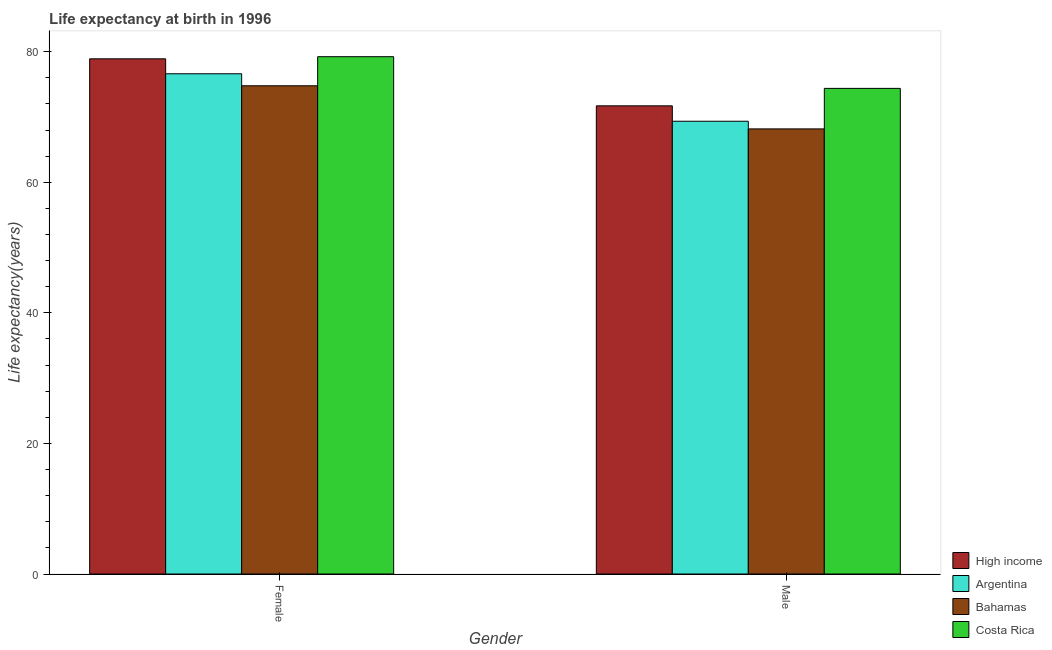How many groups of bars are there?
Your response must be concise. 2. Are the number of bars per tick equal to the number of legend labels?
Your answer should be very brief. Yes. How many bars are there on the 1st tick from the left?
Offer a terse response. 4. What is the label of the 2nd group of bars from the left?
Ensure brevity in your answer.  Male. What is the life expectancy(male) in High income?
Your response must be concise. 71.7. Across all countries, what is the maximum life expectancy(female)?
Ensure brevity in your answer.  79.23. Across all countries, what is the minimum life expectancy(male)?
Ensure brevity in your answer.  68.17. In which country was the life expectancy(male) maximum?
Offer a very short reply. Costa Rica. In which country was the life expectancy(female) minimum?
Keep it short and to the point. Bahamas. What is the total life expectancy(male) in the graph?
Offer a very short reply. 283.58. What is the difference between the life expectancy(male) in High income and that in Bahamas?
Provide a short and direct response. 3.53. What is the difference between the life expectancy(male) in Bahamas and the life expectancy(female) in High income?
Give a very brief answer. -10.73. What is the average life expectancy(female) per country?
Your answer should be compact. 77.38. What is the difference between the life expectancy(female) and life expectancy(male) in High income?
Ensure brevity in your answer.  7.2. What is the ratio of the life expectancy(male) in High income to that in Argentina?
Keep it short and to the point. 1.03. Is the life expectancy(male) in High income less than that in Argentina?
Your answer should be compact. No. What does the 1st bar from the left in Female represents?
Provide a short and direct response. High income. How many bars are there?
Make the answer very short. 8. Are all the bars in the graph horizontal?
Your response must be concise. No. How many countries are there in the graph?
Provide a short and direct response. 4. What is the difference between two consecutive major ticks on the Y-axis?
Make the answer very short. 20. Does the graph contain grids?
Your response must be concise. No. Where does the legend appear in the graph?
Provide a short and direct response. Bottom right. How are the legend labels stacked?
Keep it short and to the point. Vertical. What is the title of the graph?
Keep it short and to the point. Life expectancy at birth in 1996. Does "Comoros" appear as one of the legend labels in the graph?
Offer a very short reply. No. What is the label or title of the X-axis?
Give a very brief answer. Gender. What is the label or title of the Y-axis?
Your response must be concise. Life expectancy(years). What is the Life expectancy(years) of High income in Female?
Provide a succinct answer. 78.9. What is the Life expectancy(years) of Argentina in Female?
Offer a terse response. 76.61. What is the Life expectancy(years) in Bahamas in Female?
Ensure brevity in your answer.  74.77. What is the Life expectancy(years) in Costa Rica in Female?
Your answer should be very brief. 79.23. What is the Life expectancy(years) in High income in Male?
Your answer should be compact. 71.7. What is the Life expectancy(years) in Argentina in Male?
Your answer should be very brief. 69.34. What is the Life expectancy(years) of Bahamas in Male?
Offer a very short reply. 68.17. What is the Life expectancy(years) in Costa Rica in Male?
Provide a short and direct response. 74.37. Across all Gender, what is the maximum Life expectancy(years) in High income?
Make the answer very short. 78.9. Across all Gender, what is the maximum Life expectancy(years) of Argentina?
Offer a terse response. 76.61. Across all Gender, what is the maximum Life expectancy(years) of Bahamas?
Your response must be concise. 74.77. Across all Gender, what is the maximum Life expectancy(years) in Costa Rica?
Your answer should be compact. 79.23. Across all Gender, what is the minimum Life expectancy(years) in High income?
Your response must be concise. 71.7. Across all Gender, what is the minimum Life expectancy(years) of Argentina?
Keep it short and to the point. 69.34. Across all Gender, what is the minimum Life expectancy(years) in Bahamas?
Provide a short and direct response. 68.17. Across all Gender, what is the minimum Life expectancy(years) in Costa Rica?
Your answer should be very brief. 74.37. What is the total Life expectancy(years) in High income in the graph?
Ensure brevity in your answer.  150.6. What is the total Life expectancy(years) of Argentina in the graph?
Ensure brevity in your answer.  145.95. What is the total Life expectancy(years) in Bahamas in the graph?
Offer a terse response. 142.94. What is the total Life expectancy(years) in Costa Rica in the graph?
Give a very brief answer. 153.6. What is the difference between the Life expectancy(years) of High income in Female and that in Male?
Your answer should be very brief. 7.2. What is the difference between the Life expectancy(years) in Argentina in Female and that in Male?
Ensure brevity in your answer.  7.27. What is the difference between the Life expectancy(years) of Bahamas in Female and that in Male?
Your response must be concise. 6.61. What is the difference between the Life expectancy(years) in Costa Rica in Female and that in Male?
Make the answer very short. 4.85. What is the difference between the Life expectancy(years) of High income in Female and the Life expectancy(years) of Argentina in Male?
Make the answer very short. 9.56. What is the difference between the Life expectancy(years) in High income in Female and the Life expectancy(years) in Bahamas in Male?
Offer a very short reply. 10.73. What is the difference between the Life expectancy(years) in High income in Female and the Life expectancy(years) in Costa Rica in Male?
Give a very brief answer. 4.53. What is the difference between the Life expectancy(years) in Argentina in Female and the Life expectancy(years) in Bahamas in Male?
Your answer should be very brief. 8.44. What is the difference between the Life expectancy(years) in Argentina in Female and the Life expectancy(years) in Costa Rica in Male?
Provide a succinct answer. 2.24. What is the difference between the Life expectancy(years) in Bahamas in Female and the Life expectancy(years) in Costa Rica in Male?
Ensure brevity in your answer.  0.4. What is the average Life expectancy(years) of High income per Gender?
Offer a very short reply. 75.3. What is the average Life expectancy(years) in Argentina per Gender?
Provide a short and direct response. 72.98. What is the average Life expectancy(years) in Bahamas per Gender?
Provide a succinct answer. 71.47. What is the average Life expectancy(years) in Costa Rica per Gender?
Your answer should be compact. 76.8. What is the difference between the Life expectancy(years) in High income and Life expectancy(years) in Argentina in Female?
Your answer should be compact. 2.29. What is the difference between the Life expectancy(years) of High income and Life expectancy(years) of Bahamas in Female?
Provide a short and direct response. 4.13. What is the difference between the Life expectancy(years) in High income and Life expectancy(years) in Costa Rica in Female?
Your response must be concise. -0.33. What is the difference between the Life expectancy(years) in Argentina and Life expectancy(years) in Bahamas in Female?
Give a very brief answer. 1.84. What is the difference between the Life expectancy(years) in Argentina and Life expectancy(years) in Costa Rica in Female?
Your answer should be compact. -2.62. What is the difference between the Life expectancy(years) of Bahamas and Life expectancy(years) of Costa Rica in Female?
Keep it short and to the point. -4.45. What is the difference between the Life expectancy(years) in High income and Life expectancy(years) in Argentina in Male?
Make the answer very short. 2.36. What is the difference between the Life expectancy(years) in High income and Life expectancy(years) in Bahamas in Male?
Provide a succinct answer. 3.53. What is the difference between the Life expectancy(years) of High income and Life expectancy(years) of Costa Rica in Male?
Make the answer very short. -2.67. What is the difference between the Life expectancy(years) of Argentina and Life expectancy(years) of Bahamas in Male?
Ensure brevity in your answer.  1.17. What is the difference between the Life expectancy(years) in Argentina and Life expectancy(years) in Costa Rica in Male?
Your answer should be very brief. -5.03. What is the difference between the Life expectancy(years) of Bahamas and Life expectancy(years) of Costa Rica in Male?
Ensure brevity in your answer.  -6.21. What is the ratio of the Life expectancy(years) of High income in Female to that in Male?
Your answer should be very brief. 1.1. What is the ratio of the Life expectancy(years) of Argentina in Female to that in Male?
Your answer should be very brief. 1.1. What is the ratio of the Life expectancy(years) in Bahamas in Female to that in Male?
Your response must be concise. 1.1. What is the ratio of the Life expectancy(years) of Costa Rica in Female to that in Male?
Give a very brief answer. 1.07. What is the difference between the highest and the second highest Life expectancy(years) of High income?
Provide a succinct answer. 7.2. What is the difference between the highest and the second highest Life expectancy(years) of Argentina?
Ensure brevity in your answer.  7.27. What is the difference between the highest and the second highest Life expectancy(years) of Bahamas?
Ensure brevity in your answer.  6.61. What is the difference between the highest and the second highest Life expectancy(years) in Costa Rica?
Offer a very short reply. 4.85. What is the difference between the highest and the lowest Life expectancy(years) of High income?
Provide a succinct answer. 7.2. What is the difference between the highest and the lowest Life expectancy(years) in Argentina?
Make the answer very short. 7.27. What is the difference between the highest and the lowest Life expectancy(years) of Bahamas?
Your answer should be very brief. 6.61. What is the difference between the highest and the lowest Life expectancy(years) in Costa Rica?
Provide a short and direct response. 4.85. 